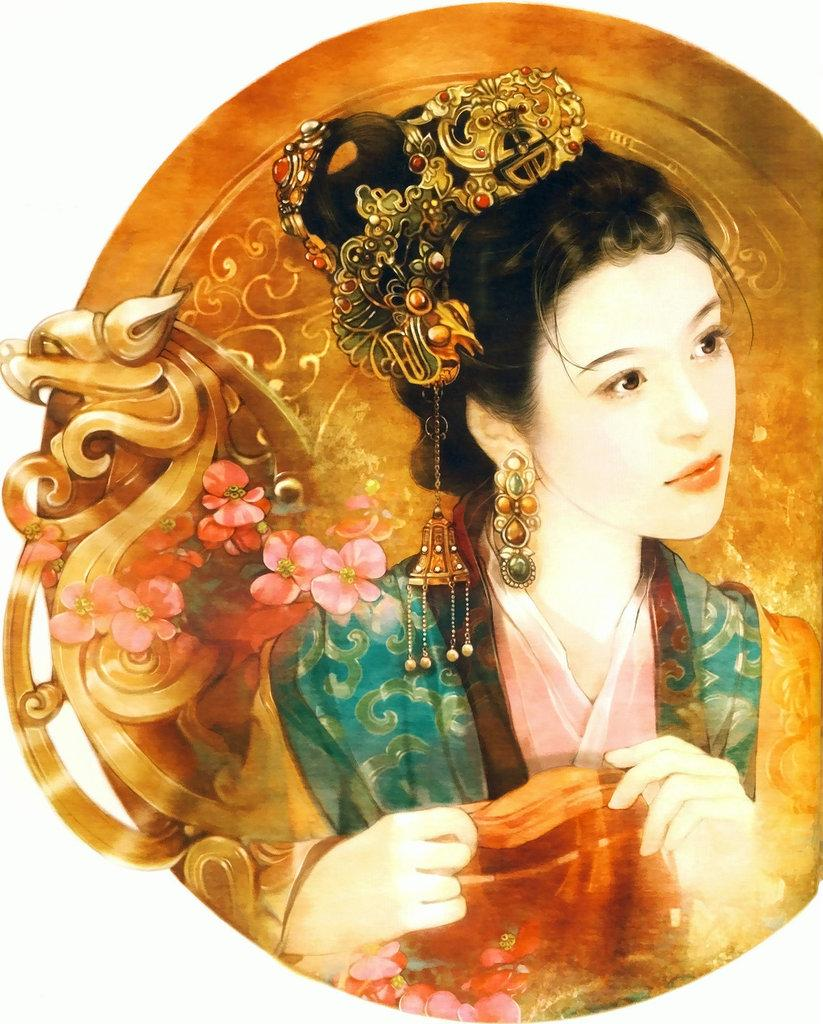What is the main feature of the object in the image? The object has a painting of a girl. Are there any other decorative elements on the object? Yes, there is a carving and a painting of flowers on the object. What can be observed about the girl in the painting? The woman in the painting is wearing jewelry. Can you tell me how many toy ships are floating in the water in the image? There is no water or toy ships present in the image; it features an object with a painting of a girl. 